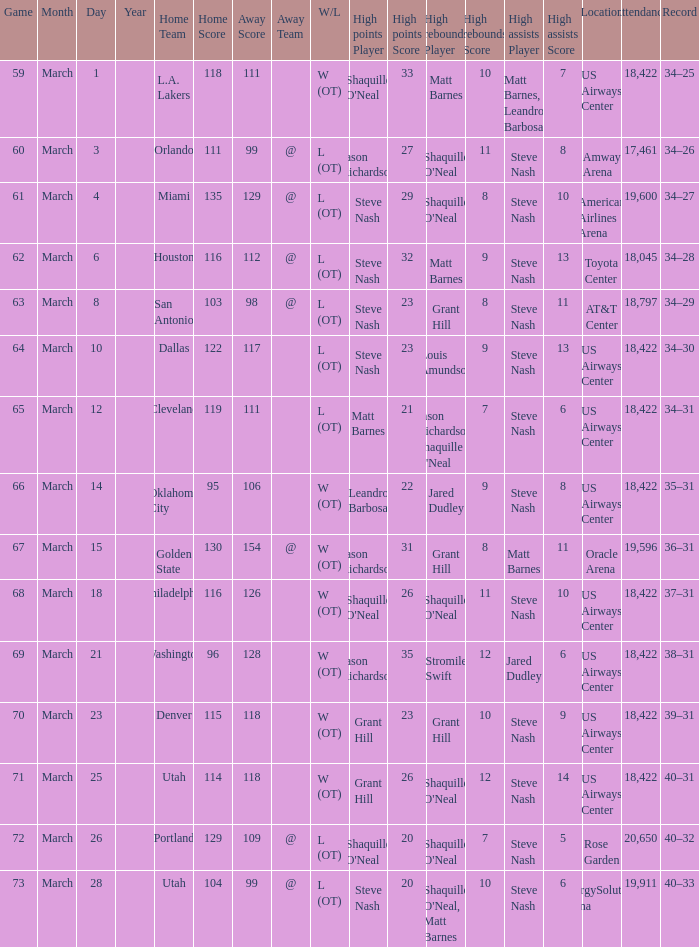After the March 15 game, what was the team's record? 36–31. Write the full table. {'header': ['Game', 'Month', 'Day', 'Year', 'Home Team', 'Home Score', 'Away Score', 'Away Team', 'W/L', 'High points Player', 'High points Score', 'High rebounds Player', 'High rebounds Score', 'High assists Player', 'High assists Score', 'Location', 'Attendance', 'Record'], 'rows': [['59', 'March', '1', '', 'L.A. Lakers', '118', '111', '', 'W (OT)', "Shaquille O'Neal", '33', 'Matt Barnes', '10', 'Matt Barnes, Leandro Barbosa', '7', 'US Airways Center', '18,422', '34–25'], ['60', 'March', '3', '', 'Orlando', '111', '99', '@', 'L (OT)', 'Jason Richardson', '27', "Shaquille O'Neal", '11', 'Steve Nash', '8', 'Amway Arena', '17,461', '34–26'], ['61', 'March', '4', '', 'Miami', '135', '129', '@', 'L (OT)', 'Steve Nash', '29', "Shaquille O'Neal", '8', 'Steve Nash', '10', 'American Airlines Arena', '19,600', '34–27'], ['62', 'March', '6', '', 'Houston', '116', '112', '@', 'L (OT)', 'Steve Nash', '32', 'Matt Barnes', '9', 'Steve Nash', '13', 'Toyota Center', '18,045', '34–28'], ['63', 'March', '8', '', 'San Antonio', '103', '98', '@', 'L (OT)', 'Steve Nash', '23', 'Grant Hill', '8', 'Steve Nash', '11', 'AT&T Center', '18,797', '34–29'], ['64', 'March', '10', '', 'Dallas', '122', '117', '', 'L (OT)', 'Steve Nash', '23', 'Louis Amundson', '9', 'Steve Nash', '13', 'US Airways Center', '18,422', '34–30'], ['65', 'March', '12', '', 'Cleveland', '119', '111', '', 'L (OT)', 'Matt Barnes', '21', "Jason Richardson, Shaquille O'Neal", '7', 'Steve Nash', '6', 'US Airways Center', '18,422', '34–31'], ['66', 'March', '14', '', 'Oklahoma City', '95', '106', '', 'W (OT)', 'Leandro Barbosa', '22', 'Jared Dudley', '9', 'Steve Nash', '8', 'US Airways Center', '18,422', '35–31'], ['67', 'March', '15', '', 'Golden State', '130', '154', '@', 'W (OT)', 'Jason Richardson', '31', 'Grant Hill', '8', 'Matt Barnes', '11', 'Oracle Arena', '19,596', '36–31'], ['68', 'March', '18', '', 'Philadelphia', '116', '126', '', 'W (OT)', "Shaquille O'Neal", '26', "Shaquille O'Neal", '11', 'Steve Nash', '10', 'US Airways Center', '18,422', '37–31'], ['69', 'March', '21', '', 'Washington', '96', '128', '', 'W (OT)', 'Jason Richardson', '35', 'Stromile Swift', '12', 'Jared Dudley', '6', 'US Airways Center', '18,422', '38–31'], ['70', 'March', '23', '', 'Denver', '115', '118', '', 'W (OT)', 'Grant Hill', '23', 'Grant Hill', '10', 'Steve Nash', '9', 'US Airways Center', '18,422', '39–31'], ['71', 'March', '25', '', 'Utah', '114', '118', '', 'W (OT)', 'Grant Hill', '26', "Shaquille O'Neal", '12', 'Steve Nash', '14', 'US Airways Center', '18,422', '40–31'], ['72', 'March', '26', '', 'Portland', '129', '109', '@', 'L (OT)', "Shaquille O'Neal", '20', "Shaquille O'Neal", '7', 'Steve Nash', '5', 'Rose Garden', '20,650', '40–32'], ['73', 'March', '28', '', 'Utah', '104', '99', '@', 'L (OT)', 'Steve Nash', '20', "Shaquille O'Neal, Matt Barnes", '10', 'Steve Nash', '6', 'EnergySolutions Arena', '19,911', '40–33']]} 